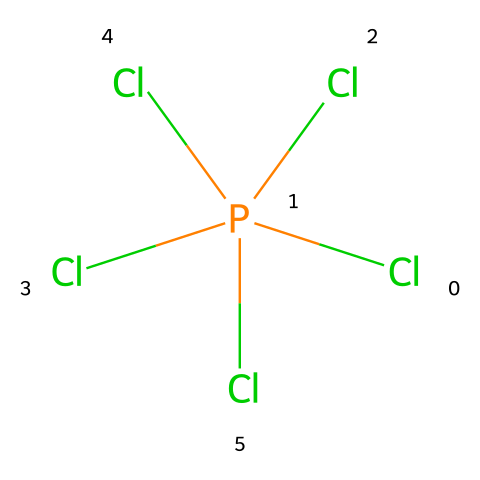How many chlorine atoms are present in phosphorus pentachloride? The SMILES notation shows five chlorine atoms connected to a phosphorus atom. Counting the 'Cl' symbols yields a total of five 'Cl' atoms.
Answer: five What is the central atom in the chemical structure of phosphorus pentachloride? The SMILES representation indicates that phosphorus ('P') is the atom that connects to the five chlorine atoms, making it the central atom of the structure.
Answer: phosphorus How many total bonds are formed in phosphorus pentachloride? Each chlorine atom forms one single bond with the phosphorus atom, so with five chlorine atoms, there are five bonds total (one bond for each chlorine).
Answer: five Is phosphorus pentachloride an example of a hypervalent compound? Phosphorus pentachloride has more than four bonds associated with the phosphorus atom (it has five), which categorizes it as a hypervalent compound.
Answer: yes What type of hybridization does the phosphorus atom in phosphorus pentachloride exhibit? The phosphorus atom forms five bonds with chlorine, which corresponds to an sp³d hybridization, as it adapts to accommodate five substituents in a trigonal bipyramidal geometry.
Answer: sp³d Which molecule can phosphorous pentachloride potentially react with due to its hypervalent nature? Due to its empty d-orbitals and ability to accept electron pairs, phosphorus pentachloride can readily react with Lewis bases (electron donors), such as amines or phosphines.
Answer: Lewis bases What is the molecular geometry of phosphorus pentachloride? The arrangement of the five bonded chlorine atoms around the phosphorus results in a trigonal bipyramidal molecular geometry, reflecting its sp³d hybridization.
Answer: trigonal bipyramidal 